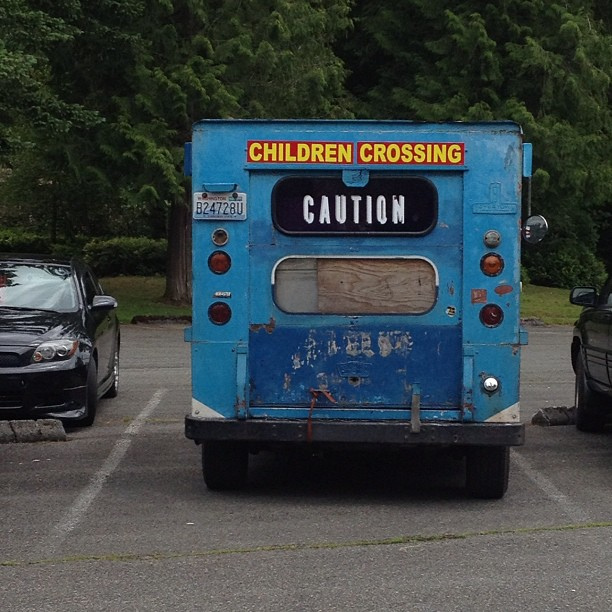Please extract the text content from this image. CAUTION CHILDREN CROSSING B24728U 